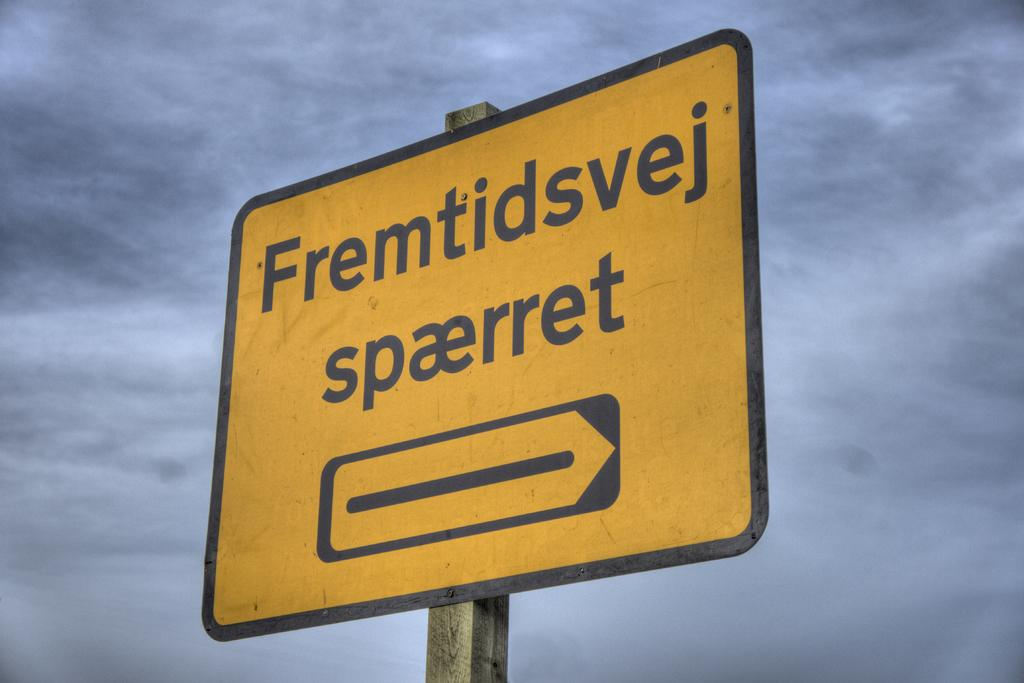<image>
Present a compact description of the photo's key features. A yellow sign which has the word Fremtidsvej on it. 